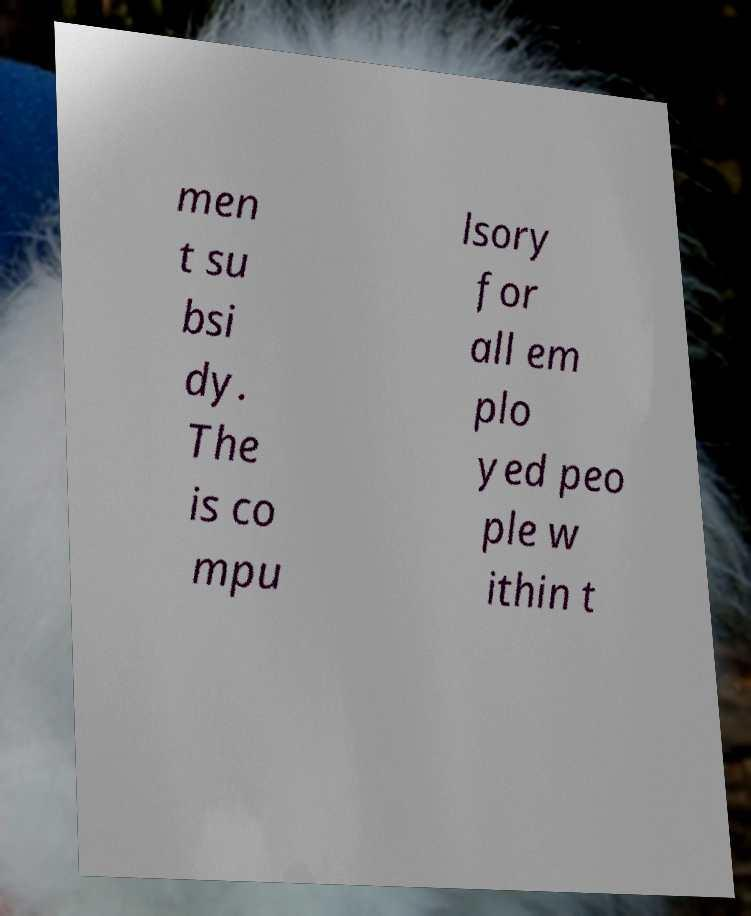Please read and relay the text visible in this image. What does it say? men t su bsi dy. The is co mpu lsory for all em plo yed peo ple w ithin t 